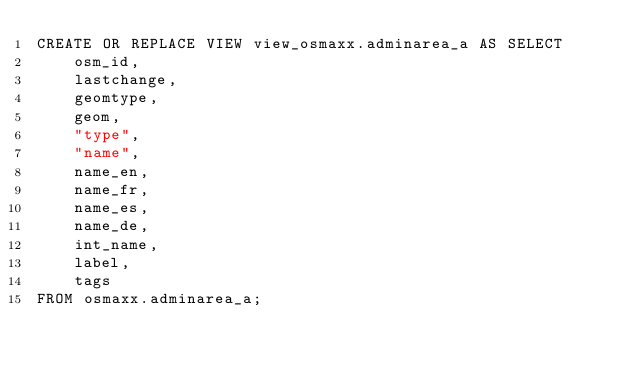Convert code to text. <code><loc_0><loc_0><loc_500><loc_500><_SQL_>CREATE OR REPLACE VIEW view_osmaxx.adminarea_a AS SELECT
    osm_id,
    lastchange,
    geomtype,
    geom,
    "type",
    "name",
    name_en,
    name_fr,
    name_es,
    name_de,
    int_name,
    label,
    tags
FROM osmaxx.adminarea_a;
</code> 